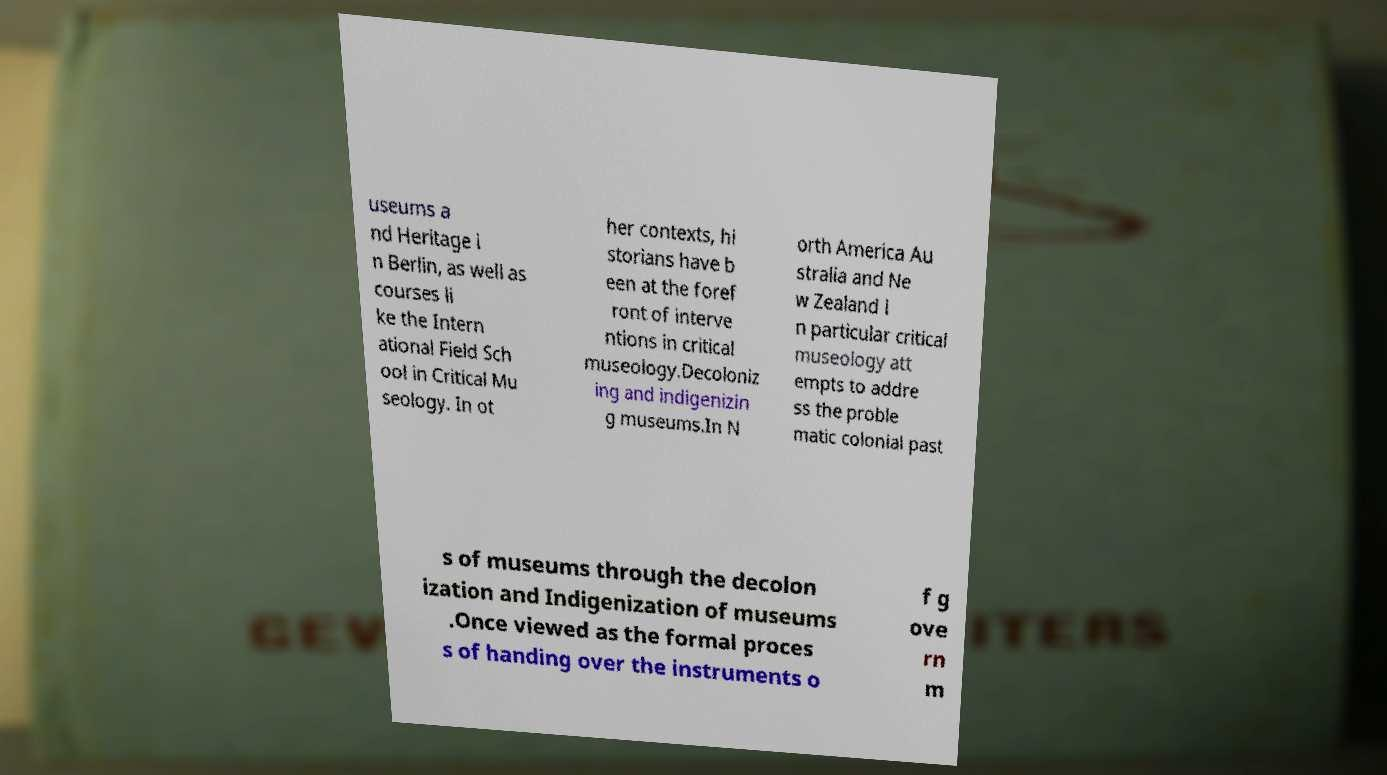Could you assist in decoding the text presented in this image and type it out clearly? useums a nd Heritage i n Berlin, as well as courses li ke the Intern ational Field Sch ool in Critical Mu seology. In ot her contexts, hi storians have b een at the foref ront of interve ntions in critical museology.Decoloniz ing and indigenizin g museums.In N orth America Au stralia and Ne w Zealand i n particular critical museology att empts to addre ss the proble matic colonial past s of museums through the decolon ization and Indigenization of museums .Once viewed as the formal proces s of handing over the instruments o f g ove rn m 